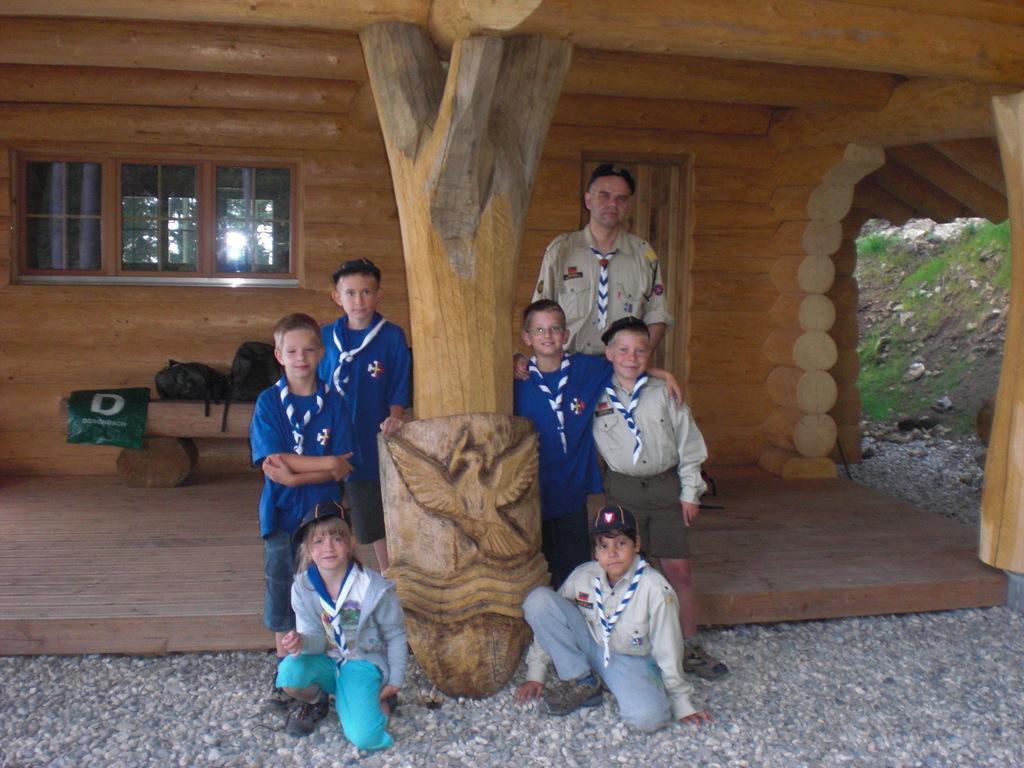How would you summarize this image in a sentence or two? In this image there are a few people standing and two are sitting on the surface of the rocks, in between them there is a wooden tree and there is an art on the tree. In the background there is a wooden house and there are a few objects placed on the wooden stem which is looking like a table. 